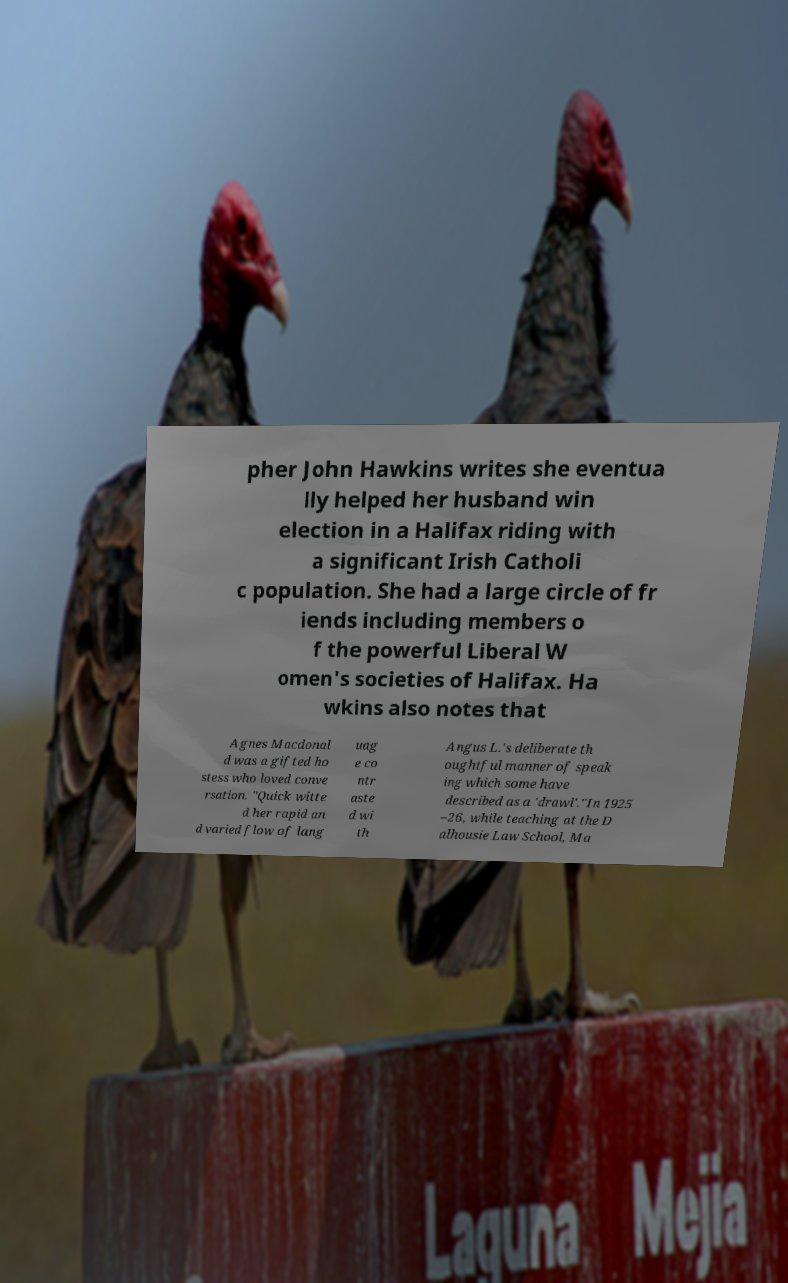Could you assist in decoding the text presented in this image and type it out clearly? pher John Hawkins writes she eventua lly helped her husband win election in a Halifax riding with a significant Irish Catholi c population. She had a large circle of fr iends including members o f the powerful Liberal W omen's societies of Halifax. Ha wkins also notes that Agnes Macdonal d was a gifted ho stess who loved conve rsation. "Quick witte d her rapid an d varied flow of lang uag e co ntr aste d wi th Angus L.'s deliberate th oughtful manner of speak ing which some have described as a 'drawl'."In 1925 –26, while teaching at the D alhousie Law School, Ma 